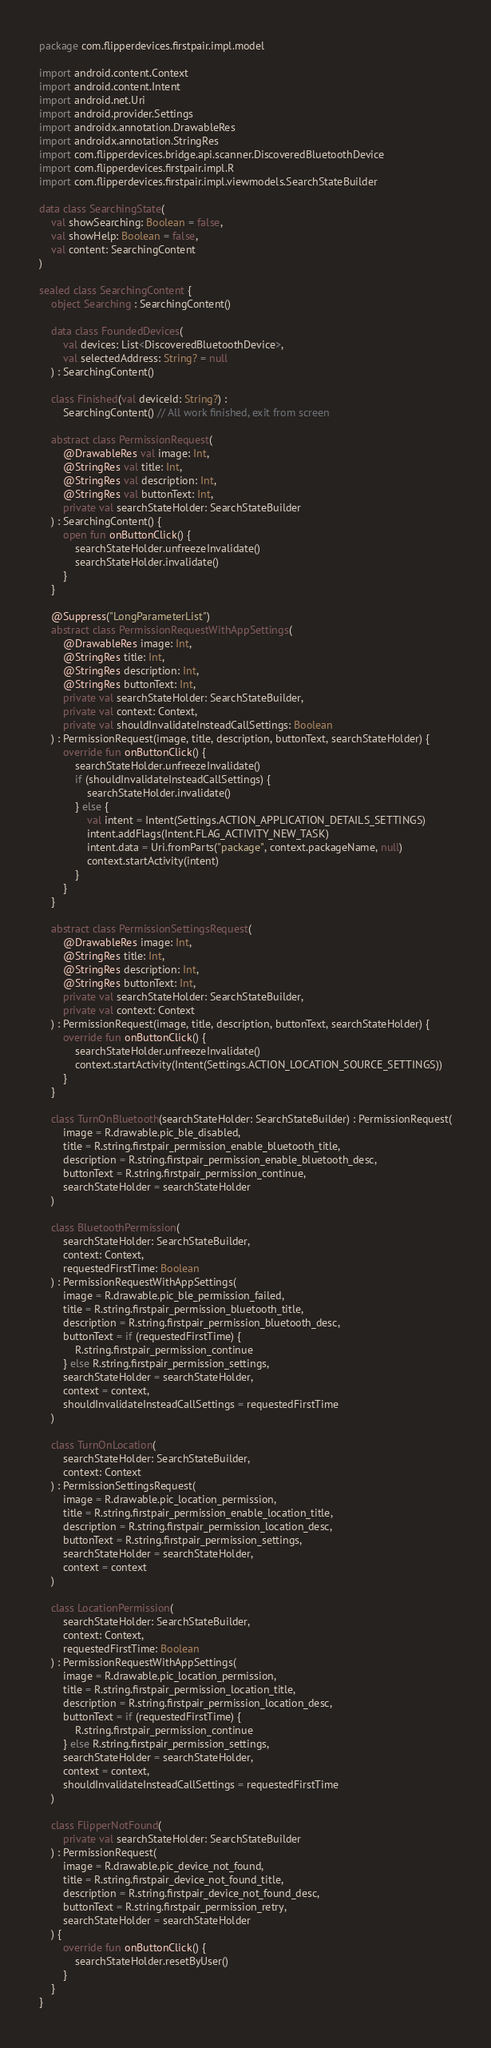<code> <loc_0><loc_0><loc_500><loc_500><_Kotlin_>package com.flipperdevices.firstpair.impl.model

import android.content.Context
import android.content.Intent
import android.net.Uri
import android.provider.Settings
import androidx.annotation.DrawableRes
import androidx.annotation.StringRes
import com.flipperdevices.bridge.api.scanner.DiscoveredBluetoothDevice
import com.flipperdevices.firstpair.impl.R
import com.flipperdevices.firstpair.impl.viewmodels.SearchStateBuilder

data class SearchingState(
    val showSearching: Boolean = false,
    val showHelp: Boolean = false,
    val content: SearchingContent
)

sealed class SearchingContent {
    object Searching : SearchingContent()

    data class FoundedDevices(
        val devices: List<DiscoveredBluetoothDevice>,
        val selectedAddress: String? = null
    ) : SearchingContent()

    class Finished(val deviceId: String?) :
        SearchingContent() // All work finished, exit from screen

    abstract class PermissionRequest(
        @DrawableRes val image: Int,
        @StringRes val title: Int,
        @StringRes val description: Int,
        @StringRes val buttonText: Int,
        private val searchStateHolder: SearchStateBuilder
    ) : SearchingContent() {
        open fun onButtonClick() {
            searchStateHolder.unfreezeInvalidate()
            searchStateHolder.invalidate()
        }
    }

    @Suppress("LongParameterList")
    abstract class PermissionRequestWithAppSettings(
        @DrawableRes image: Int,
        @StringRes title: Int,
        @StringRes description: Int,
        @StringRes buttonText: Int,
        private val searchStateHolder: SearchStateBuilder,
        private val context: Context,
        private val shouldInvalidateInsteadCallSettings: Boolean
    ) : PermissionRequest(image, title, description, buttonText, searchStateHolder) {
        override fun onButtonClick() {
            searchStateHolder.unfreezeInvalidate()
            if (shouldInvalidateInsteadCallSettings) {
                searchStateHolder.invalidate()
            } else {
                val intent = Intent(Settings.ACTION_APPLICATION_DETAILS_SETTINGS)
                intent.addFlags(Intent.FLAG_ACTIVITY_NEW_TASK)
                intent.data = Uri.fromParts("package", context.packageName, null)
                context.startActivity(intent)
            }
        }
    }

    abstract class PermissionSettingsRequest(
        @DrawableRes image: Int,
        @StringRes title: Int,
        @StringRes description: Int,
        @StringRes buttonText: Int,
        private val searchStateHolder: SearchStateBuilder,
        private val context: Context
    ) : PermissionRequest(image, title, description, buttonText, searchStateHolder) {
        override fun onButtonClick() {
            searchStateHolder.unfreezeInvalidate()
            context.startActivity(Intent(Settings.ACTION_LOCATION_SOURCE_SETTINGS))
        }
    }

    class TurnOnBluetooth(searchStateHolder: SearchStateBuilder) : PermissionRequest(
        image = R.drawable.pic_ble_disabled,
        title = R.string.firstpair_permission_enable_bluetooth_title,
        description = R.string.firstpair_permission_enable_bluetooth_desc,
        buttonText = R.string.firstpair_permission_continue,
        searchStateHolder = searchStateHolder
    )

    class BluetoothPermission(
        searchStateHolder: SearchStateBuilder,
        context: Context,
        requestedFirstTime: Boolean
    ) : PermissionRequestWithAppSettings(
        image = R.drawable.pic_ble_permission_failed,
        title = R.string.firstpair_permission_bluetooth_title,
        description = R.string.firstpair_permission_bluetooth_desc,
        buttonText = if (requestedFirstTime) {
            R.string.firstpair_permission_continue
        } else R.string.firstpair_permission_settings,
        searchStateHolder = searchStateHolder,
        context = context,
        shouldInvalidateInsteadCallSettings = requestedFirstTime
    )

    class TurnOnLocation(
        searchStateHolder: SearchStateBuilder,
        context: Context
    ) : PermissionSettingsRequest(
        image = R.drawable.pic_location_permission,
        title = R.string.firstpair_permission_enable_location_title,
        description = R.string.firstpair_permission_location_desc,
        buttonText = R.string.firstpair_permission_settings,
        searchStateHolder = searchStateHolder,
        context = context
    )

    class LocationPermission(
        searchStateHolder: SearchStateBuilder,
        context: Context,
        requestedFirstTime: Boolean
    ) : PermissionRequestWithAppSettings(
        image = R.drawable.pic_location_permission,
        title = R.string.firstpair_permission_location_title,
        description = R.string.firstpair_permission_location_desc,
        buttonText = if (requestedFirstTime) {
            R.string.firstpair_permission_continue
        } else R.string.firstpair_permission_settings,
        searchStateHolder = searchStateHolder,
        context = context,
        shouldInvalidateInsteadCallSettings = requestedFirstTime
    )

    class FlipperNotFound(
        private val searchStateHolder: SearchStateBuilder
    ) : PermissionRequest(
        image = R.drawable.pic_device_not_found,
        title = R.string.firstpair_device_not_found_title,
        description = R.string.firstpair_device_not_found_desc,
        buttonText = R.string.firstpair_permission_retry,
        searchStateHolder = searchStateHolder
    ) {
        override fun onButtonClick() {
            searchStateHolder.resetByUser()
        }
    }
}
</code> 